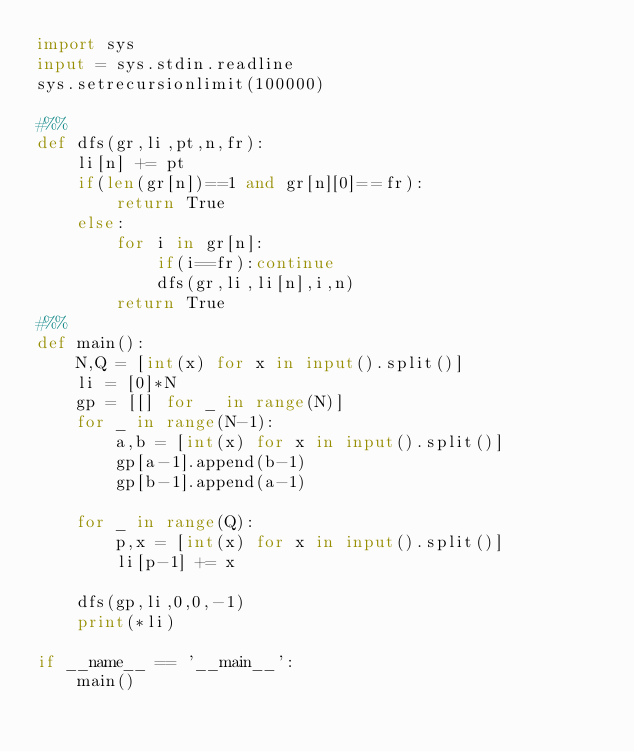<code> <loc_0><loc_0><loc_500><loc_500><_Python_>import sys
input = sys.stdin.readline
sys.setrecursionlimit(100000)

#%%
def dfs(gr,li,pt,n,fr):
    li[n] += pt
    if(len(gr[n])==1 and gr[n][0]==fr):
        return True
    else:
        for i in gr[n]:
            if(i==fr):continue
            dfs(gr,li,li[n],i,n)
        return True
#%%
def main():
    N,Q = [int(x) for x in input().split()]
    li = [0]*N
    gp = [[] for _ in range(N)]
    for _ in range(N-1):
        a,b = [int(x) for x in input().split()]
        gp[a-1].append(b-1)
        gp[b-1].append(a-1)

    for _ in range(Q):
        p,x = [int(x) for x in input().split()]
        li[p-1] += x

    dfs(gp,li,0,0,-1)
    print(*li)

if __name__ == '__main__':
    main()
</code> 